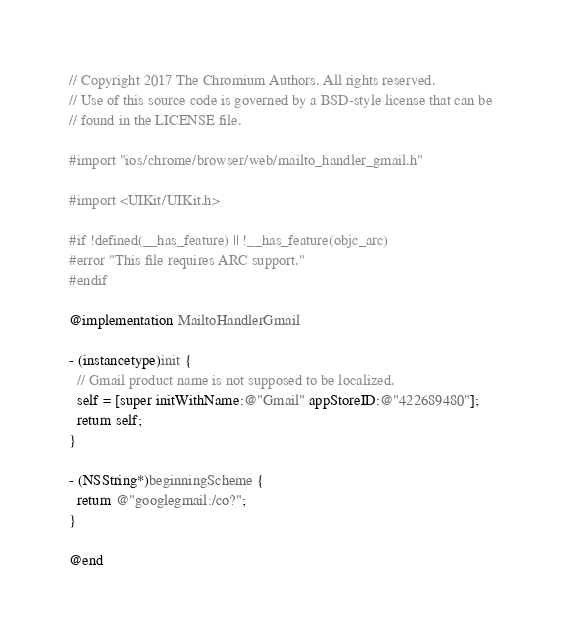Convert code to text. <code><loc_0><loc_0><loc_500><loc_500><_ObjectiveC_>// Copyright 2017 The Chromium Authors. All rights reserved.
// Use of this source code is governed by a BSD-style license that can be
// found in the LICENSE file.

#import "ios/chrome/browser/web/mailto_handler_gmail.h"

#import <UIKit/UIKit.h>

#if !defined(__has_feature) || !__has_feature(objc_arc)
#error "This file requires ARC support."
#endif

@implementation MailtoHandlerGmail

- (instancetype)init {
  // Gmail product name is not supposed to be localized.
  self = [super initWithName:@"Gmail" appStoreID:@"422689480"];
  return self;
}

- (NSString*)beginningScheme {
  return @"googlegmail:/co?";
}

@end
</code> 